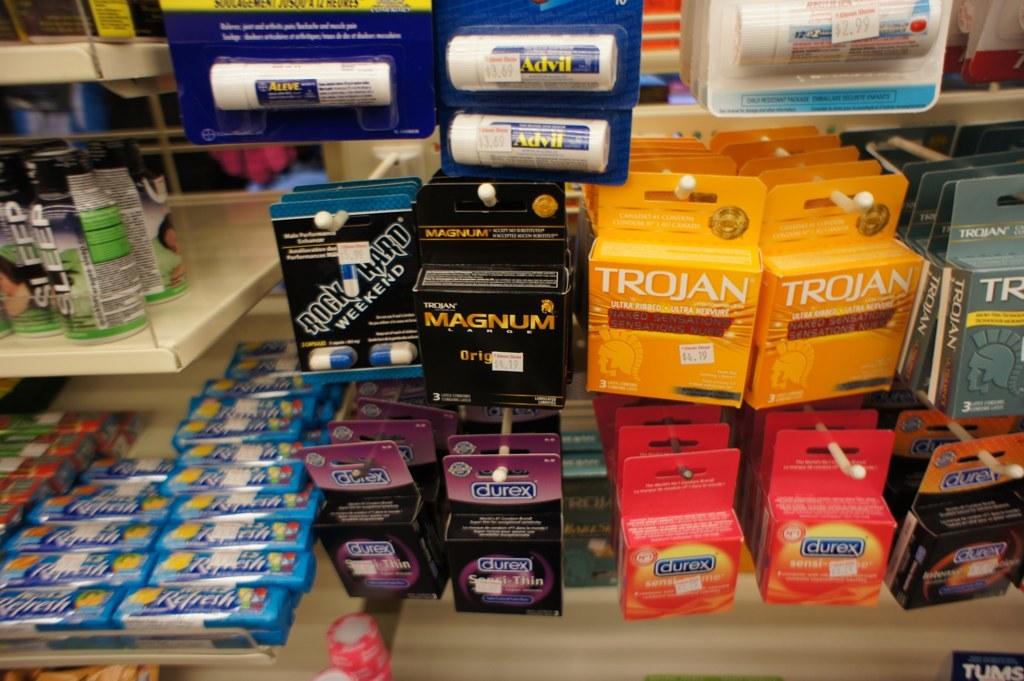What does the yellow box say?
Provide a succinct answer. Trojan. What kind of condoms are in the black box?
Ensure brevity in your answer.  Magnum. 